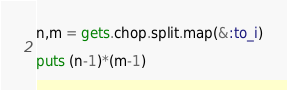Convert code to text. <code><loc_0><loc_0><loc_500><loc_500><_Ruby_>n,m = gets.chop.split.map(&:to_i)

puts (n-1)*(m-1)</code> 